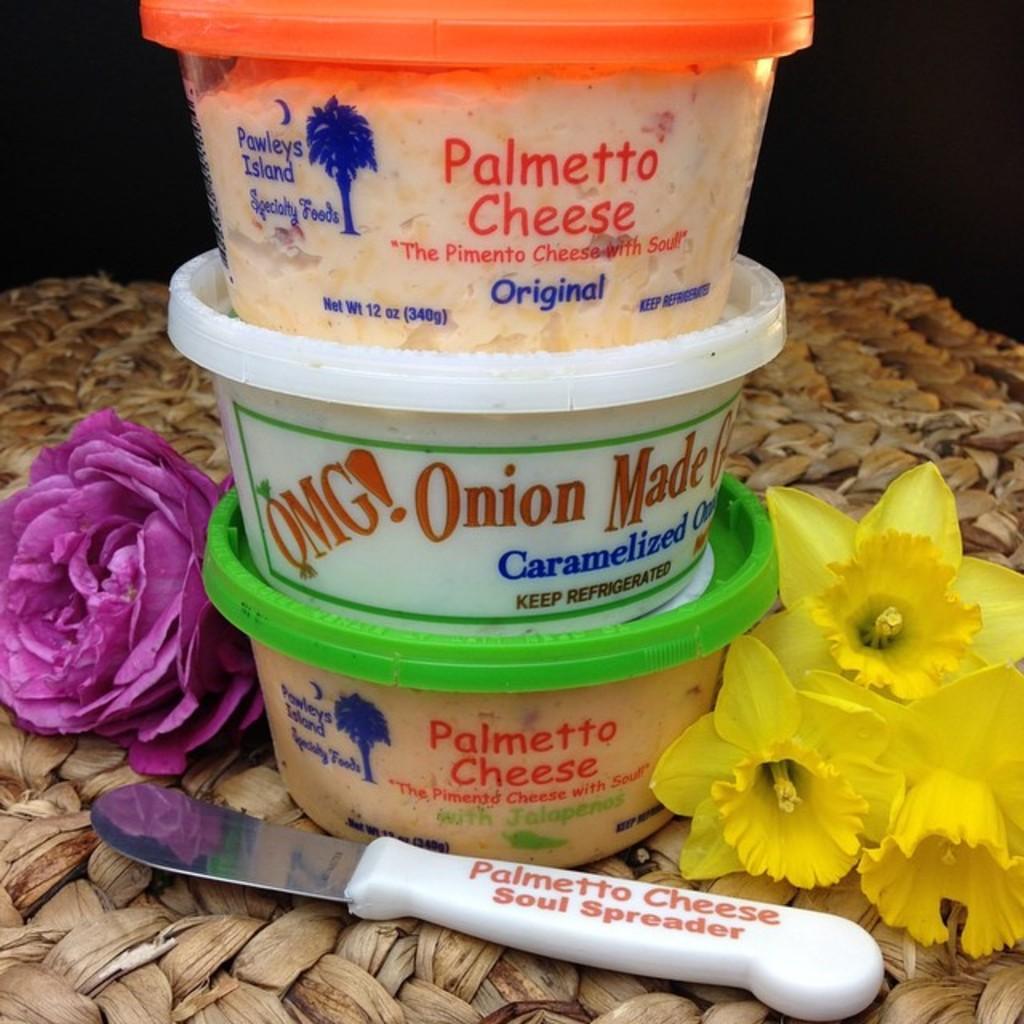What kind of food is in the green container?
Provide a short and direct response. Palmetto cheese. What flavor of palmetto cheese is in the green containter?
Offer a very short reply. Jalapeno. 